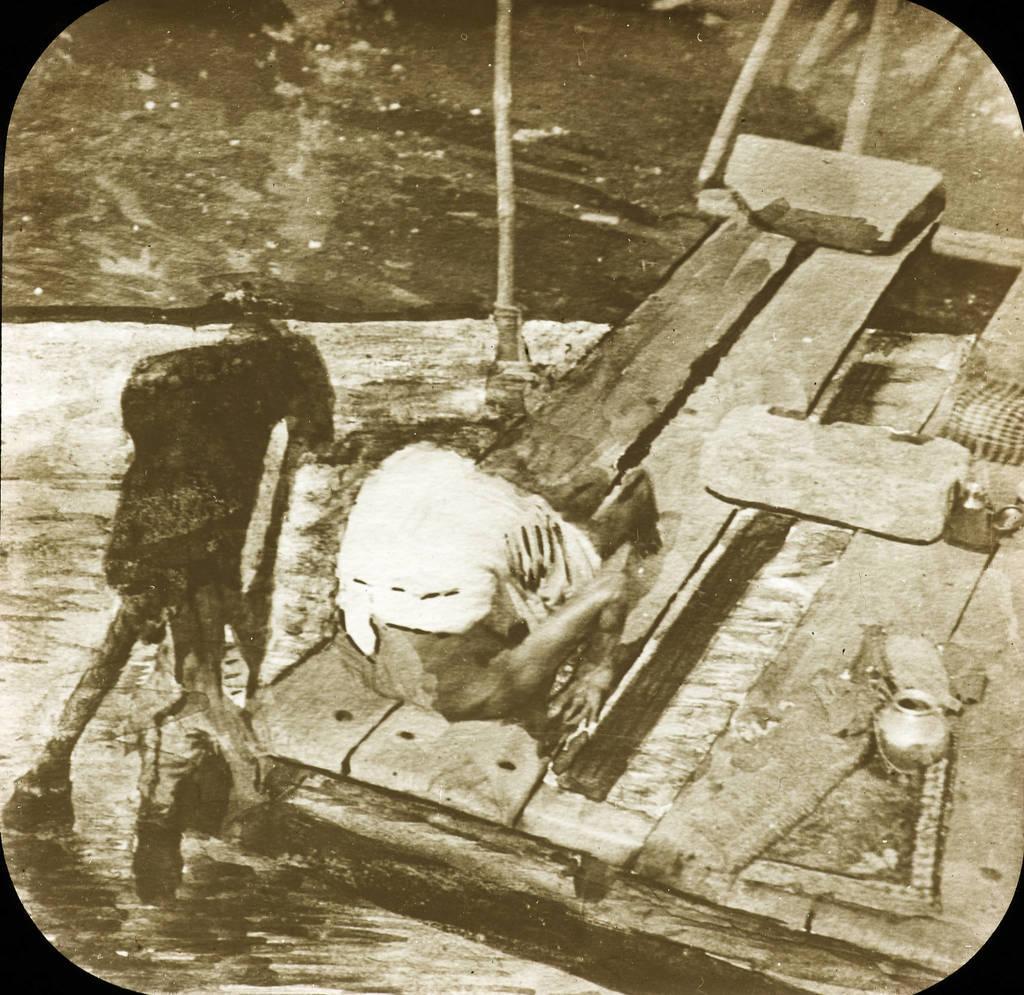How would you summarize this image in a sentence or two? This picture describes about black and white photo. 